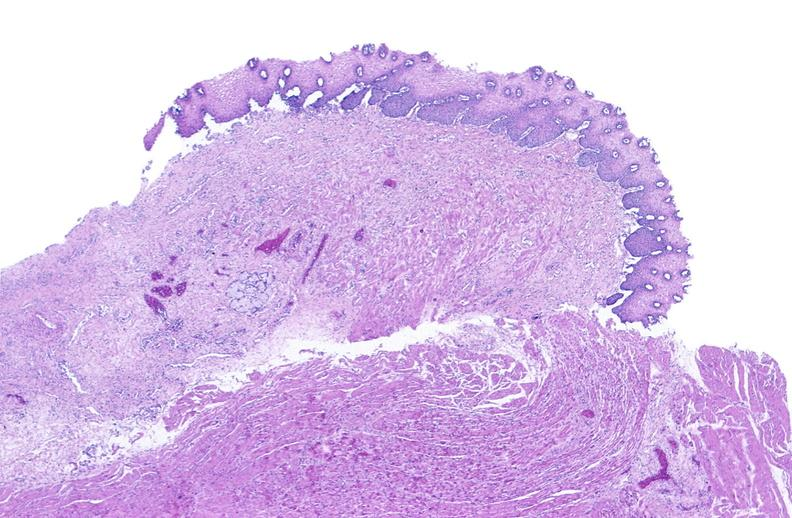s coronary artery anomalous origin left from pulmonary artery present?
Answer the question using a single word or phrase. No 